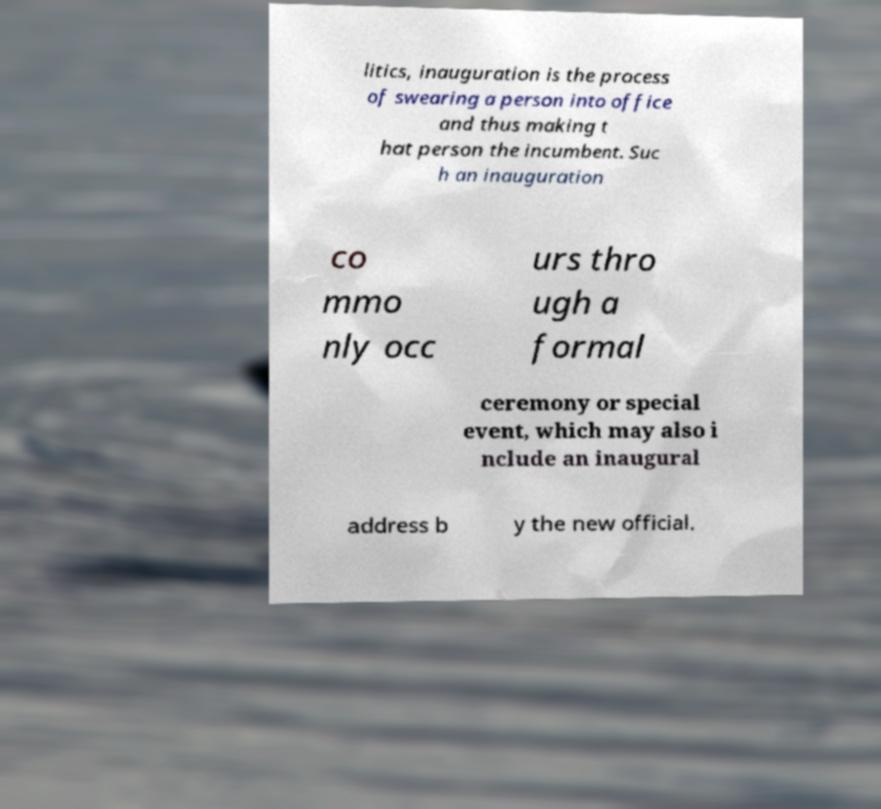There's text embedded in this image that I need extracted. Can you transcribe it verbatim? litics, inauguration is the process of swearing a person into office and thus making t hat person the incumbent. Suc h an inauguration co mmo nly occ urs thro ugh a formal ceremony or special event, which may also i nclude an inaugural address b y the new official. 